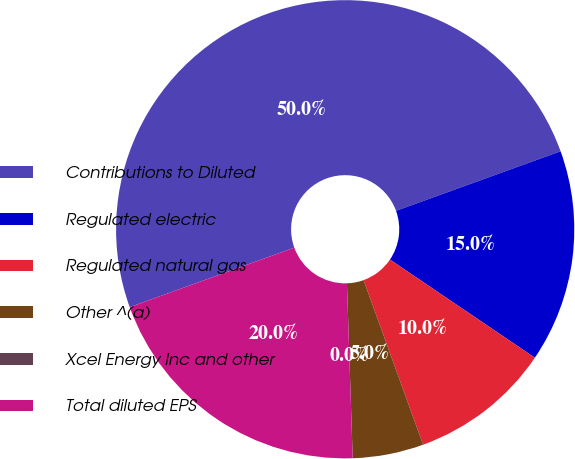Convert chart. <chart><loc_0><loc_0><loc_500><loc_500><pie_chart><fcel>Contributions to Diluted<fcel>Regulated electric<fcel>Regulated natural gas<fcel>Other ^(a)<fcel>Xcel Energy Inc and other<fcel>Total diluted EPS<nl><fcel>49.99%<fcel>15.0%<fcel>10.0%<fcel>5.0%<fcel>0.0%<fcel>20.0%<nl></chart> 